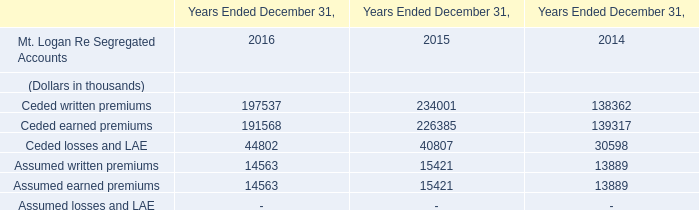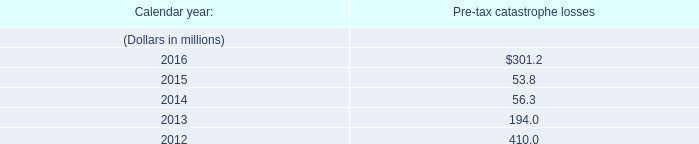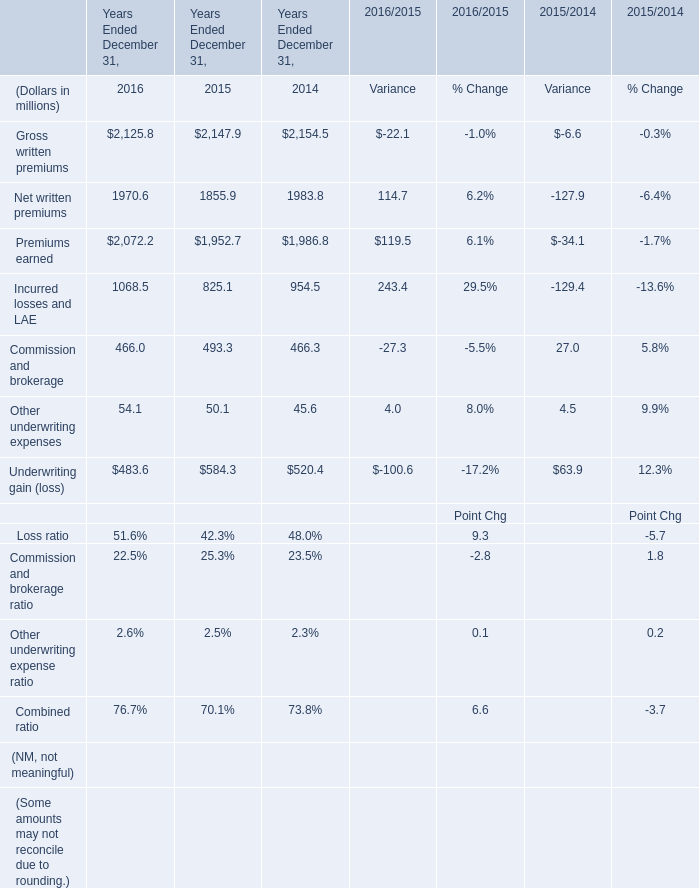what's the total amount of Incurred losses and LAE of Years Ended December 31, 2016, Ceded losses and LAE of Years Ended December 31, 2015, and Ceded earned premiums of Years Ended December 31, 2014 ? 
Computations: ((1068.5 + 40807.0) + 139317.0)
Answer: 181192.5. 